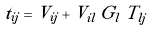<formula> <loc_0><loc_0><loc_500><loc_500>t _ { i j } = V _ { i j } + V _ { i l } \, G _ { l } \, T _ { l j }</formula> 